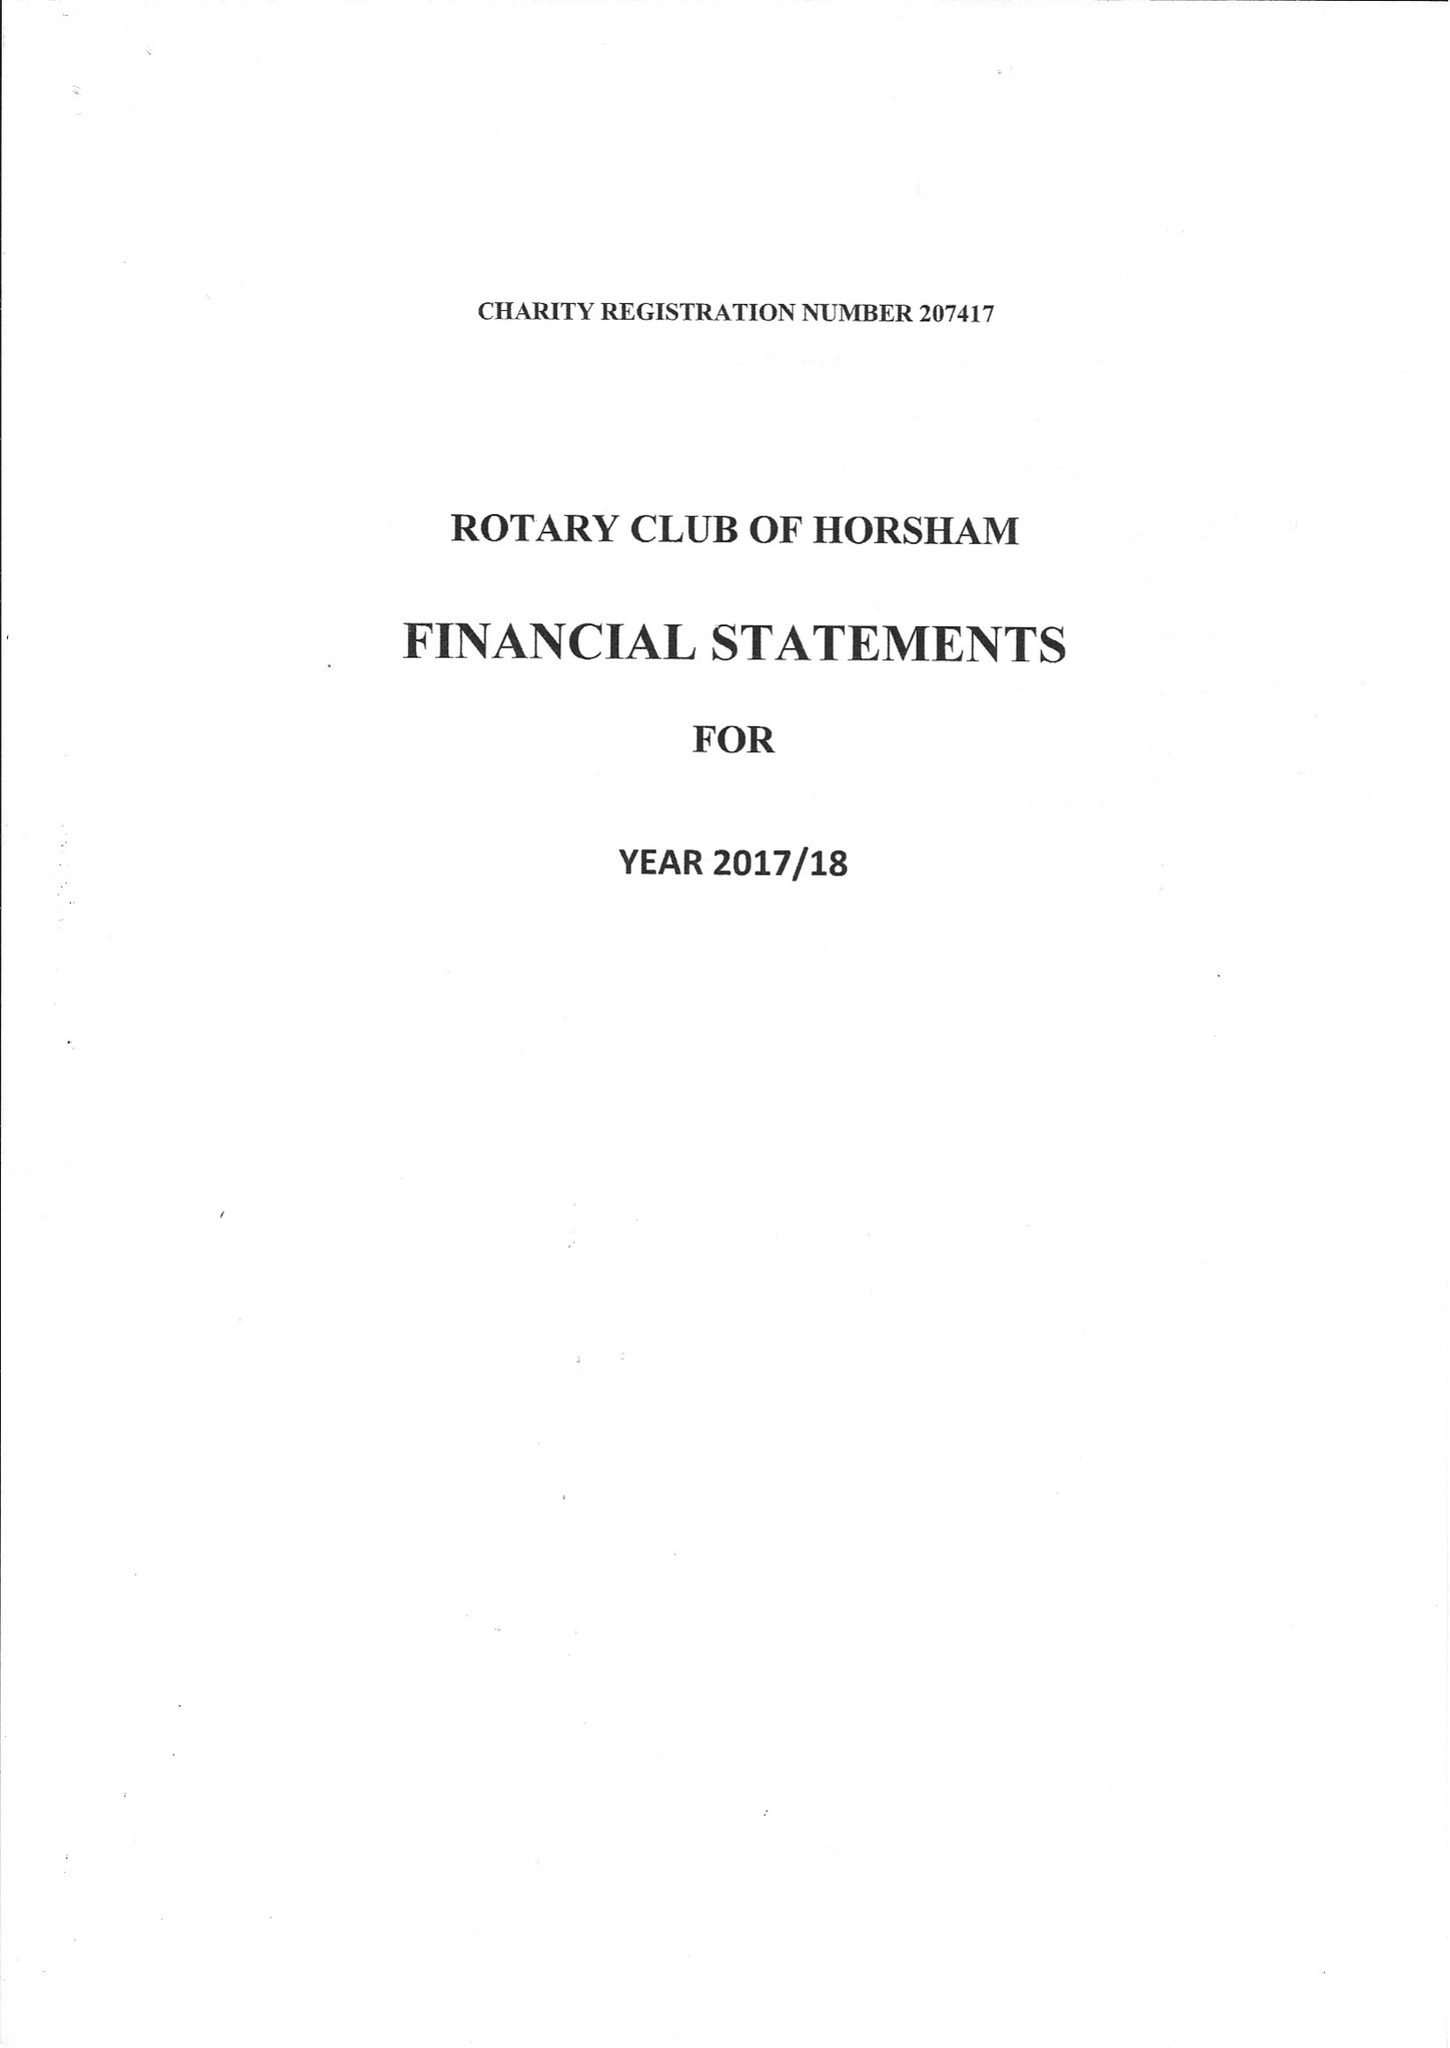What is the value for the address__street_line?
Answer the question using a single word or phrase. None 